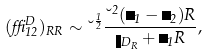Convert formula to latex. <formula><loc_0><loc_0><loc_500><loc_500>( \delta _ { 1 2 } ^ { D } ) _ { R R } \sim \lambda ^ { \frac { 1 } { 2 } } \frac { \lambda ^ { 2 } ( \psi _ { 1 } - \psi _ { 2 } ) R } { \eta _ { D _ { R } } + \psi _ { 1 } R } ,</formula> 